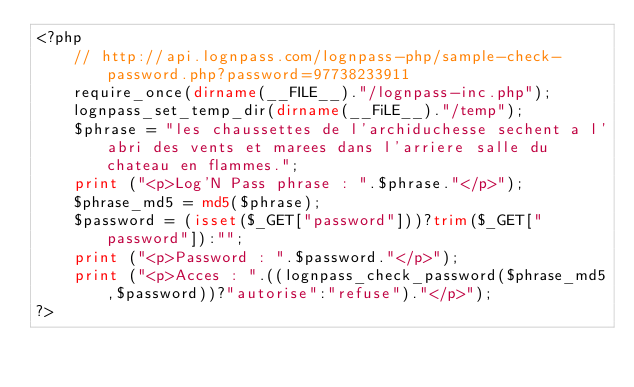<code> <loc_0><loc_0><loc_500><loc_500><_PHP_><?php
	// http://api.lognpass.com/lognpass-php/sample-check-password.php?password=97738233911
	require_once(dirname(__FILE__)."/lognpass-inc.php");
	lognpass_set_temp_dir(dirname(__FiLE__)."/temp");
	$phrase = "les chaussettes de l'archiduchesse sechent a l'abri des vents et marees dans l'arriere salle du chateau en flammes.";
	print ("<p>Log'N Pass phrase : ".$phrase."</p>");
	$phrase_md5 = md5($phrase);
	$password = (isset($_GET["password"]))?trim($_GET["password"]):"";
	print ("<p>Password : ".$password."</p>");
	print ("<p>Acces : ".((lognpass_check_password($phrase_md5,$password))?"autorise":"refuse")."</p>");
?></code> 